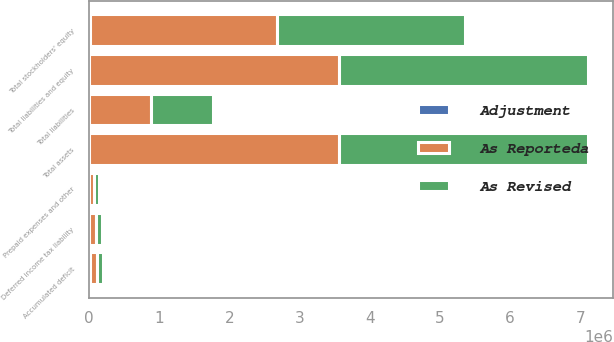Convert chart to OTSL. <chart><loc_0><loc_0><loc_500><loc_500><stacked_bar_chart><ecel><fcel>Prepaid expenses and other<fcel>Total assets<fcel>Deferred income tax liability<fcel>Total liabilities<fcel>Accumulated deficit<fcel>Total stockholders' equity<fcel>Total liabilities and equity<nl><fcel>As Reporteda<fcel>68147<fcel>3.55424e+06<fcel>91104<fcel>883028<fcel>97485<fcel>2.67122e+06<fcel>3.55424e+06<nl><fcel>Adjustment<fcel>3916<fcel>3916<fcel>7243<fcel>7243<fcel>11159<fcel>11159<fcel>3916<nl><fcel>As Revised<fcel>72063<fcel>3.55816e+06<fcel>83861<fcel>875785<fcel>86326<fcel>2.68237e+06<fcel>3.55816e+06<nl></chart> 